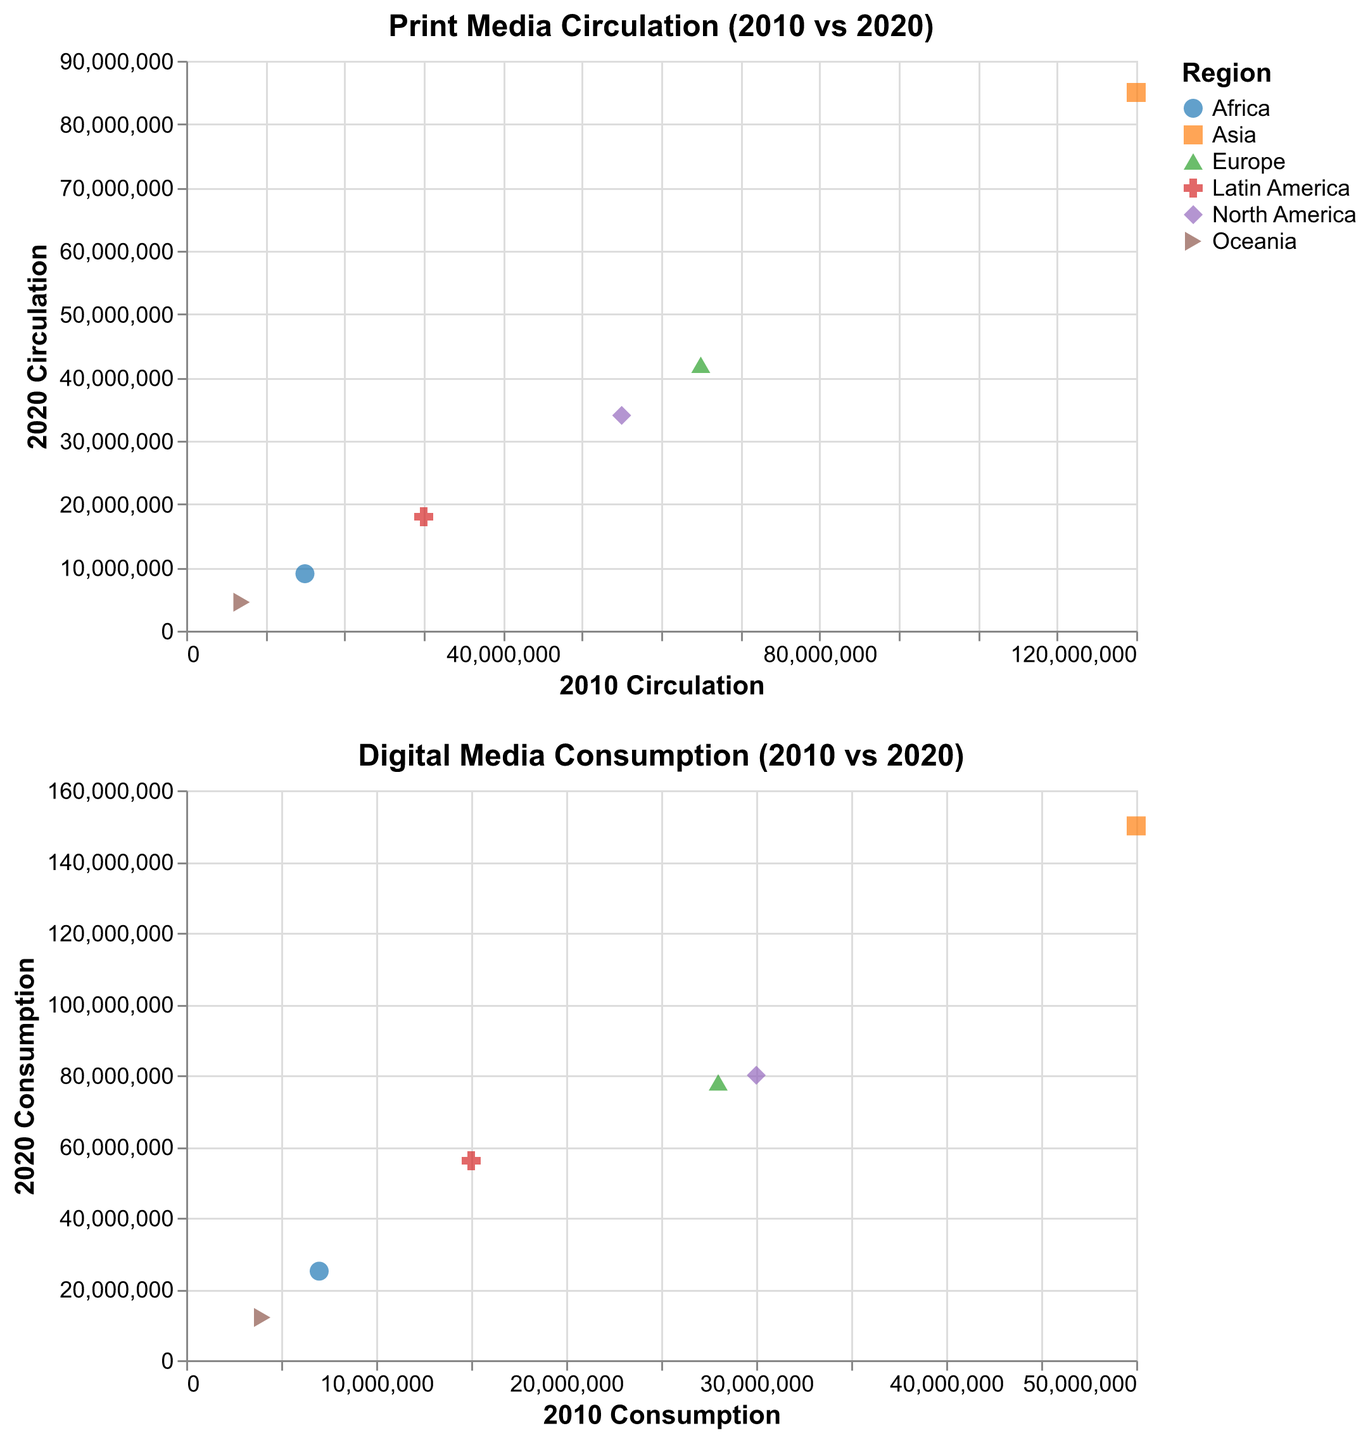What region had the highest print media circulation in 2010? Look at the x-axis of the 'Print Media Circulation (2010 vs 2020)' plot and identify the region with the highest value.
Answer: Asia How much did digital media consumption increase in Asia from 2010 to 2020? Subtract the 2010 digital media consumption value from the 2020 digital media consumption value for Asia.
Answer: 100,000,000 Which region experienced the largest decline in print media circulation from 2010 to 2020? Calculate the difference between the 2010 and 2020 print media circulation values for each region and identify the region with the largest negative difference.
Answer: Asia What is the trend in digital media consumption in Europe from 2010 to 2020? Look at the y-axis of the 'Digital Media Consumption (2010 vs 2020)' plot for Europe to see if there is an increase or decrease from 2010 to 2020.
Answer: Increase Did any region have an increase in print media circulation from 2010 to 2020? Check the 'Print Media Circulation (2010 vs 2020)' plot for any region where the y-axis value is higher than the x-axis value.
Answer: No Which region had the lowest digital media consumption in 2010? Look at the x-axis of the 'Digital Media Consumption (2010 vs 2020)' plot and identify the region with the lowest value.
Answer: Oceania Compare the change in print media circulation between North America and Latin America from 2010 to 2020. Calculate the difference in print media circulation values for both North America and Latin America from 2010 to 2020, then compare the differences.
Answer: North America: -21,000,000; Latin America: -12,000,000 How many regions experienced an increase in digital media consumption from 2010 to 2020? Count the number of regions in the 'Digital Media Consumption (2010 vs 2020)' plot where the y-axis value is higher than the x-axis value.
Answer: 6 What is the average print media circulation in 2020 for Africa and Oceania? Add the 2020 print media circulation values for Africa and Oceania, then divide by 2. (9,000,000 + 4,500,000) / 2 = 6,750,000
Answer: 6,750,000 Which region had the smallest increase in digital media consumption from 2010 to 2020? Subtract the 2010 digital media consumption value from the 2020 digital media consumption value for each region and identify the region with the smallest increase.
Answer: Oceania 